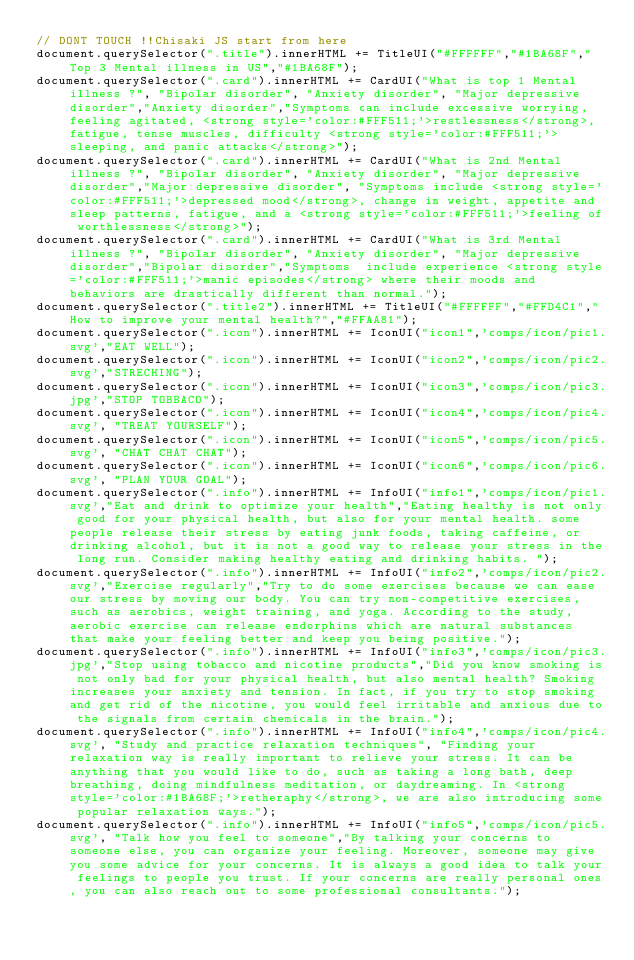Convert code to text. <code><loc_0><loc_0><loc_500><loc_500><_JavaScript_>// DONT TOUCH !!Chisaki JS start from here
document.querySelector(".title").innerHTML += TitleUI("#FFFFFF","#1BA68F","Top 3 Mental illness in US","#1BA68F");
document.querySelector(".card").innerHTML += CardUI("What is top 1 Mental illness ?", "Bipolar disorder", "Anxiety disorder", "Major depressive disorder","Anxiety disorder","Symptoms can include excessive worrying, feeling agitated, <strong style='color:#FFF511;'>restlessness</strong>, fatigue, tense muscles, difficulty <strong style='color:#FFF511;'>sleeping, and panic attacks</strong>");
document.querySelector(".card").innerHTML += CardUI("What is 2nd Mental illness ?", "Bipolar disorder", "Anxiety disorder", "Major depressive disorder","Major depressive disorder", "Symptoms include <strong style='color:#FFF511;'>depressed mood</strong>, change in weight, appetite and sleep patterns, fatigue, and a <strong style='color:#FFF511;'>feeling of worthlessness</strong>");
document.querySelector(".card").innerHTML += CardUI("What is 3rd Mental illness ?", "Bipolar disorder", "Anxiety disorder", "Major depressive disorder","Bipolar disorder","Symptoms  include experience <strong style='color:#FFF511;'>manic episodes</strong> where their moods and behaviors are drastically different than normal.");
document.querySelector(".title2").innerHTML += TitleUI("#FFFFFF","#FFD4C1","How to improve your mental health?","#FFAA81");
document.querySelector(".icon").innerHTML += IconUI("icon1",'comps/icon/pic1.svg',"EAT WELL");
document.querySelector(".icon").innerHTML += IconUI("icon2",'comps/icon/pic2.svg',"STRECHING");
document.querySelector(".icon").innerHTML += IconUI("icon3",'comps/icon/pic3.jpg',"STOP TOBBACO");
document.querySelector(".icon").innerHTML += IconUI("icon4",'comps/icon/pic4.svg', "TREAT YOURSELF");
document.querySelector(".icon").innerHTML += IconUI("icon5",'comps/icon/pic5.svg', "CHAT CHAT CHAT");
document.querySelector(".icon").innerHTML += IconUI("icon6",'comps/icon/pic6.svg', "PLAN YOUR GOAL");
document.querySelector(".info").innerHTML += InfoUI("info1",'comps/icon/pic1.svg',"Eat and drink to optimize your health","Eating healthy is not only good for your physical health, but also for your mental health. some people release their stress by eating junk foods, taking caffeine, or drinking alcohol, but it is not a good way to release your stress in the long run. Consider making healthy eating and drinking habits. ");
document.querySelector(".info").innerHTML += InfoUI("info2",'comps/icon/pic2.svg',"Exercise regularly","Try to do some exercises because we can ease our stress by moving our body. You can try non-competitive exercises, such as aerobics, weight training, and yoga. According to the study, aerobic exercise can release endorphins which are natural substances that make your feeling better and keep you being positive.");
document.querySelector(".info").innerHTML += InfoUI("info3",'comps/icon/pic3.jpg',"Stop using tobacco and nicotine products","Did you know smoking is not only bad for your physical health, but also mental health? Smoking increases your anxiety and tension. In fact, if you try to stop smoking and get rid of the nicotine, you would feel irritable and anxious due to the signals from certain chemicals in the brain.");
document.querySelector(".info").innerHTML += InfoUI("info4",'comps/icon/pic4.svg', "Study and practice relaxation techniques", "Finding your relaxation way is really important to relieve your stress. It can be anything that you would like to do, such as taking a long bath, deep breathing, doing mindfulness meditation, or daydreaming. In <strong style='color:#1BA68F;'>retheraphy</strong>, we are also introducing some popular relaxation ways.");
document.querySelector(".info").innerHTML += InfoUI("info5",'comps/icon/pic5.svg', "Talk how you feel to someone","By talking your concerns to someone else, you can organize your feeling. Moreover, someone may give you some advice for your concerns. It is always a good idea to talk your feelings to people you trust. If your concerns are really personal ones, you can also reach out to some professional consultants.");</code> 